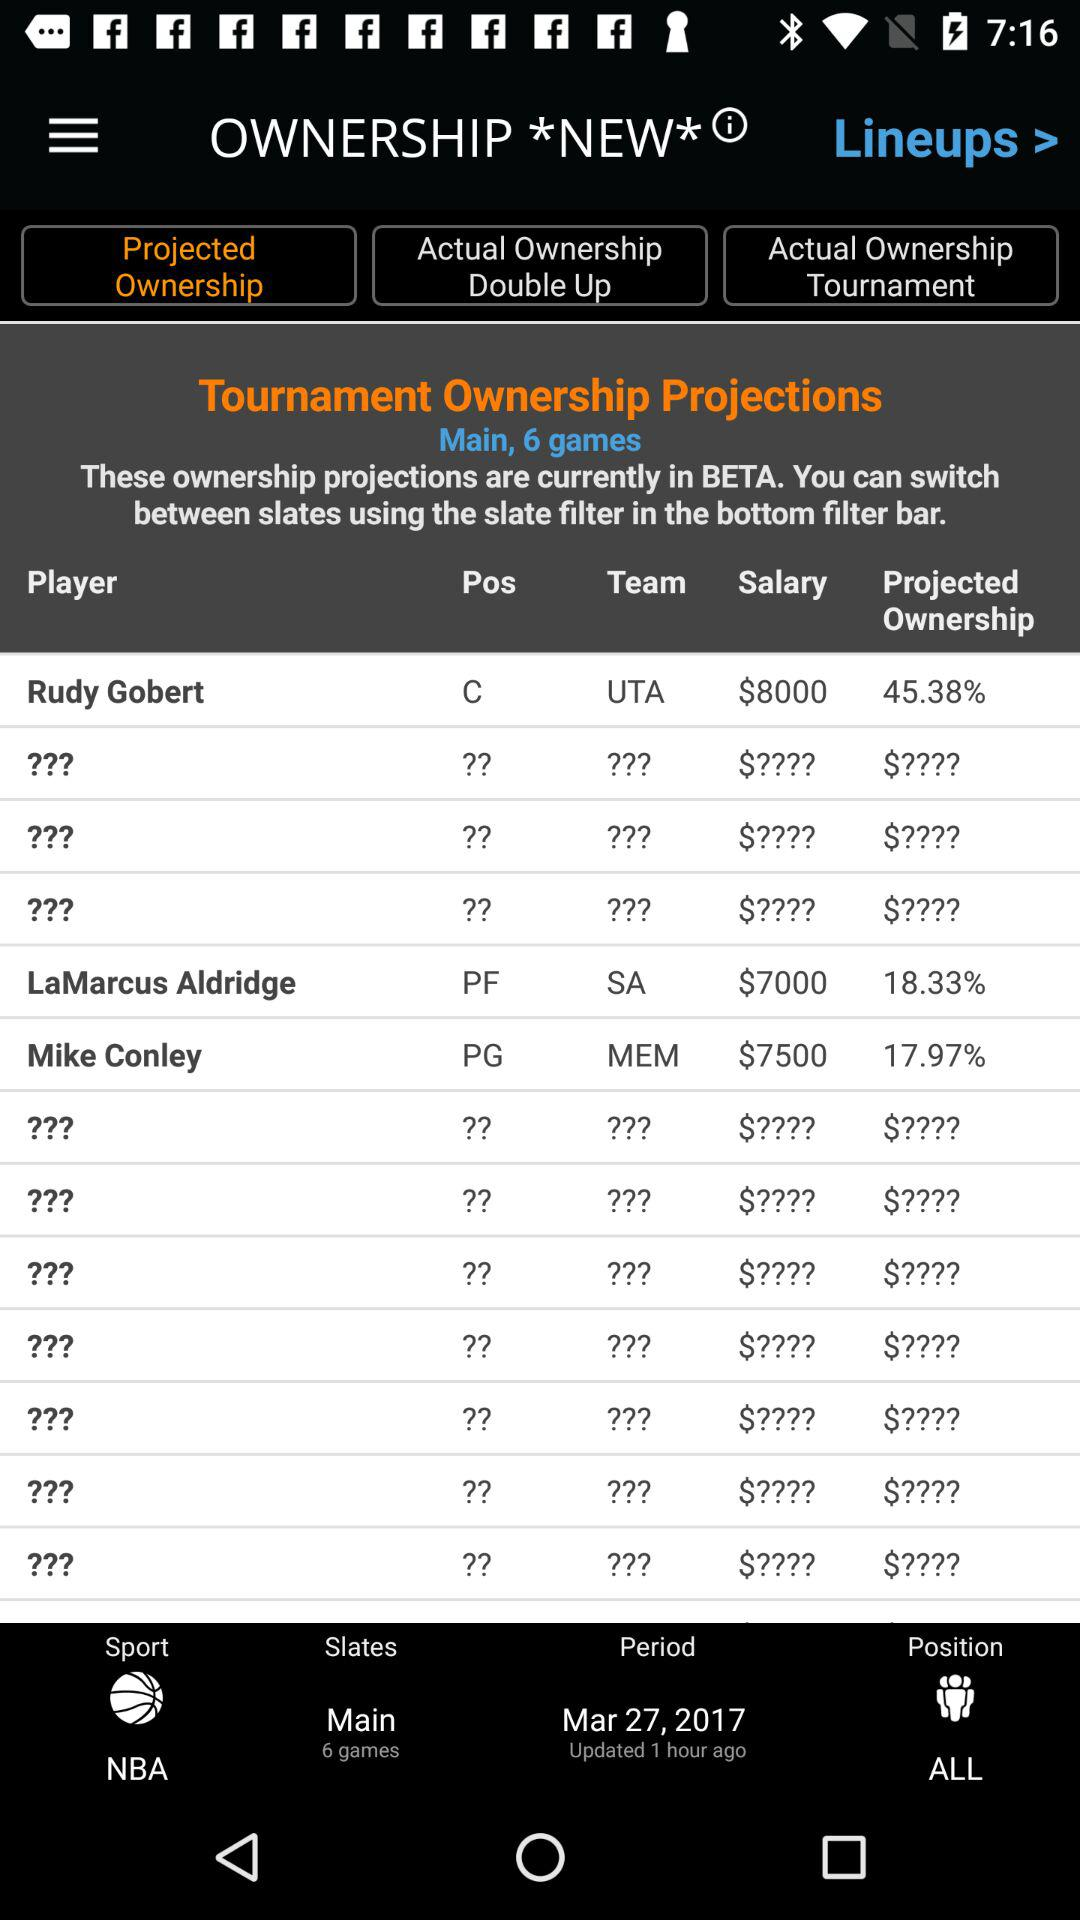How many games are there? There are six games. 